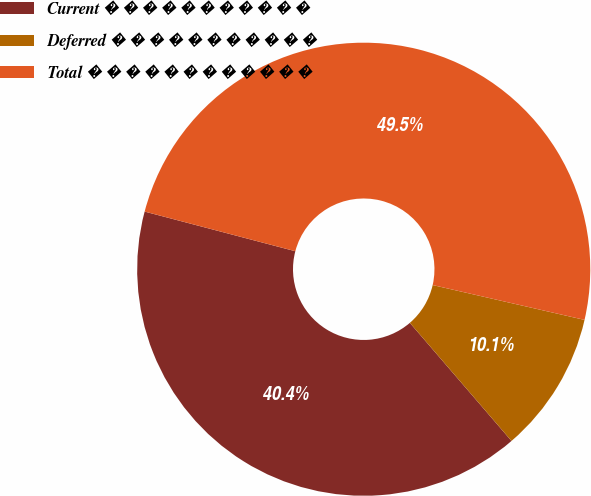Convert chart. <chart><loc_0><loc_0><loc_500><loc_500><pie_chart><fcel>Current � � � � � � � � � � �<fcel>Deferred � � � � � � � � � � �<fcel>Total � � � � � � � � � � � �<nl><fcel>40.4%<fcel>10.1%<fcel>49.49%<nl></chart> 